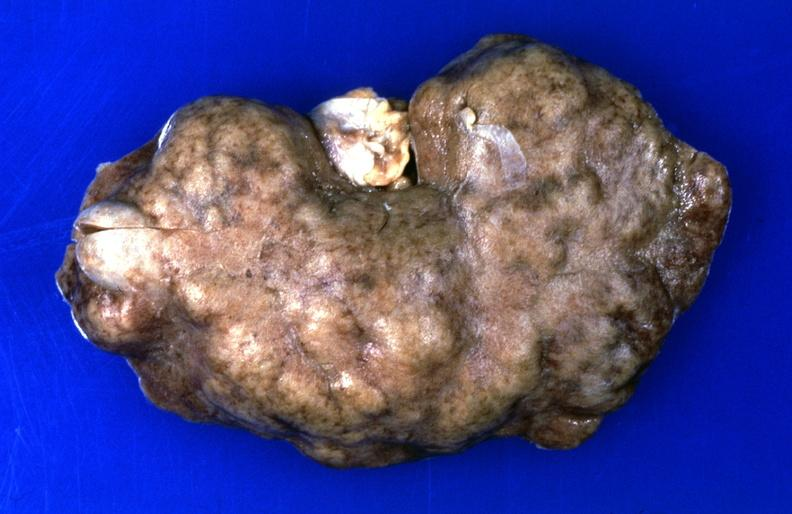what does this image show?
Answer the question using a single word or phrase. Kidney 